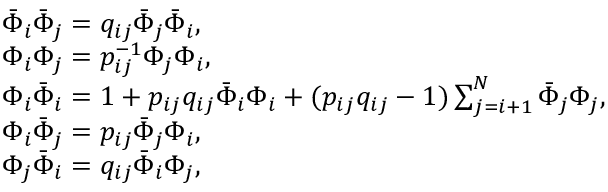<formula> <loc_0><loc_0><loc_500><loc_500>\begin{array} { l } { { \bar { \Phi } _ { i } \bar { \Phi } _ { j } = q _ { i j } \bar { \Phi } _ { j } \bar { \Phi } _ { i } , } } \\ { { \Phi _ { i } \Phi _ { j } = p _ { i j } ^ { - 1 } \Phi _ { j } \Phi _ { i } , } } \\ { { \Phi _ { i } \bar { \Phi } _ { i } = 1 + p _ { i j } q _ { i j } \bar { \Phi } _ { i } \Phi _ { i } + ( p _ { i j } q _ { i j } - 1 ) \sum _ { j = i + 1 } ^ { N } \bar { \Phi } _ { j } \Phi _ { j } , } } \\ { { \Phi _ { i } \bar { \Phi } _ { j } = p _ { i j } \bar { \Phi } _ { j } \Phi _ { i } , } } \\ { { \Phi _ { j } \bar { \Phi } _ { i } = q _ { i j } \bar { \Phi } _ { i } \Phi _ { j } , } } \end{array}</formula> 